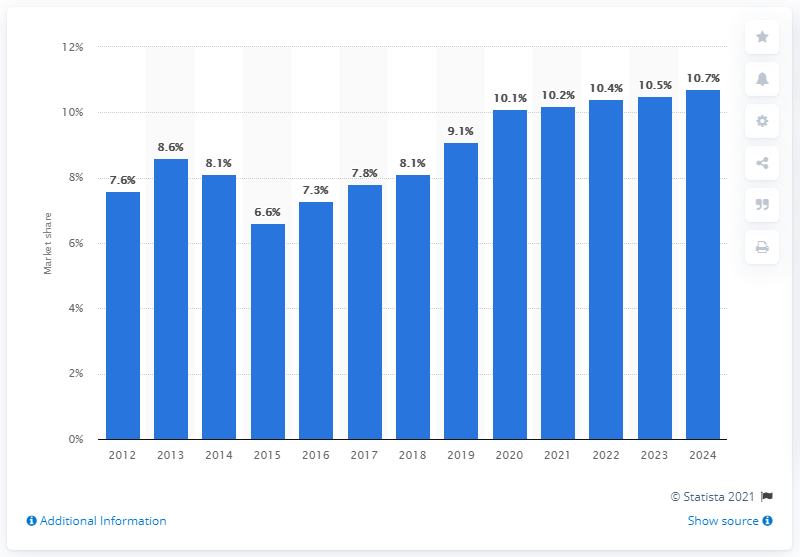Mention a couple of crucial points in this snapshot. Estee Lauder's share of the global skin care products market in 2017 was 7.8%. 